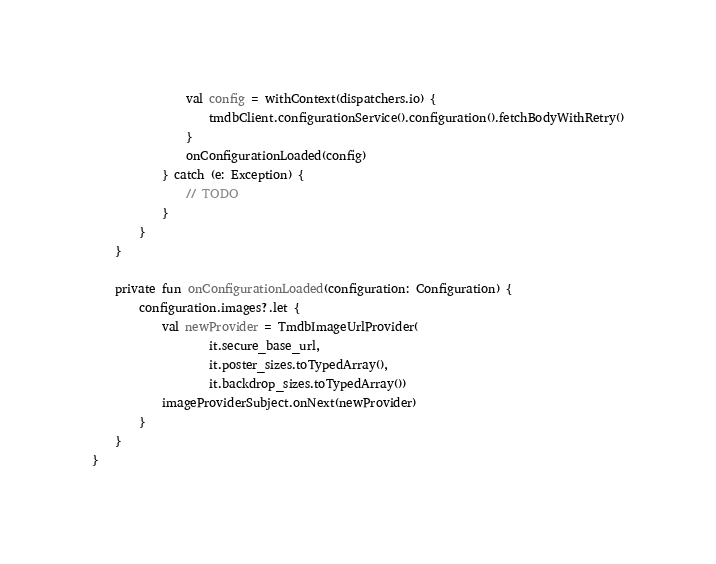<code> <loc_0><loc_0><loc_500><loc_500><_Kotlin_>                val config = withContext(dispatchers.io) {
                    tmdbClient.configurationService().configuration().fetchBodyWithRetry()
                }
                onConfigurationLoaded(config)
            } catch (e: Exception) {
                // TODO
            }
        }
    }

    private fun onConfigurationLoaded(configuration: Configuration) {
        configuration.images?.let {
            val newProvider = TmdbImageUrlProvider(
                    it.secure_base_url,
                    it.poster_sizes.toTypedArray(),
                    it.backdrop_sizes.toTypedArray())
            imageProviderSubject.onNext(newProvider)
        }
    }
}</code> 